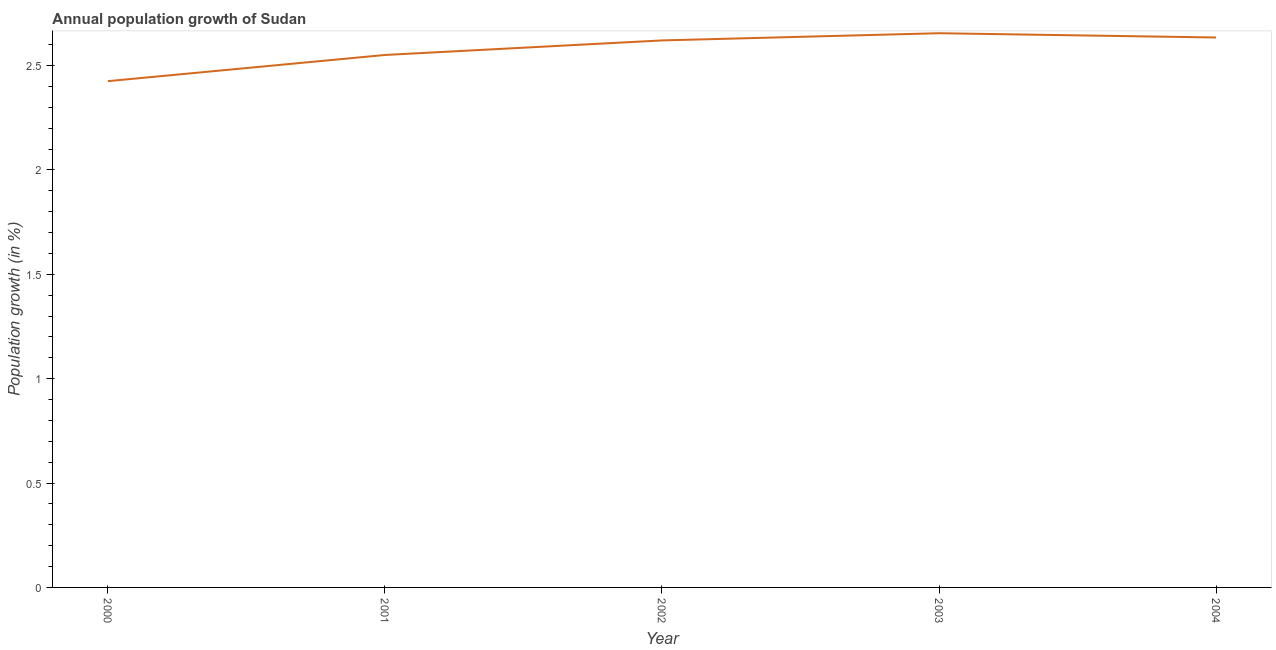What is the population growth in 2004?
Keep it short and to the point. 2.63. Across all years, what is the maximum population growth?
Your answer should be compact. 2.66. Across all years, what is the minimum population growth?
Make the answer very short. 2.43. In which year was the population growth minimum?
Provide a short and direct response. 2000. What is the sum of the population growth?
Keep it short and to the point. 12.89. What is the difference between the population growth in 2001 and 2002?
Give a very brief answer. -0.07. What is the average population growth per year?
Provide a succinct answer. 2.58. What is the median population growth?
Make the answer very short. 2.62. In how many years, is the population growth greater than 1.1 %?
Offer a very short reply. 5. Do a majority of the years between 2003 and 2000 (inclusive) have population growth greater than 1 %?
Provide a succinct answer. Yes. What is the ratio of the population growth in 2002 to that in 2003?
Your answer should be compact. 0.99. Is the population growth in 2000 less than that in 2002?
Your answer should be very brief. Yes. What is the difference between the highest and the second highest population growth?
Give a very brief answer. 0.02. Is the sum of the population growth in 2001 and 2002 greater than the maximum population growth across all years?
Keep it short and to the point. Yes. What is the difference between the highest and the lowest population growth?
Offer a terse response. 0.23. What is the difference between two consecutive major ticks on the Y-axis?
Make the answer very short. 0.5. Are the values on the major ticks of Y-axis written in scientific E-notation?
Ensure brevity in your answer.  No. What is the title of the graph?
Provide a succinct answer. Annual population growth of Sudan. What is the label or title of the X-axis?
Your response must be concise. Year. What is the label or title of the Y-axis?
Keep it short and to the point. Population growth (in %). What is the Population growth (in %) in 2000?
Your answer should be very brief. 2.43. What is the Population growth (in %) of 2001?
Give a very brief answer. 2.55. What is the Population growth (in %) of 2002?
Your response must be concise. 2.62. What is the Population growth (in %) in 2003?
Ensure brevity in your answer.  2.66. What is the Population growth (in %) in 2004?
Keep it short and to the point. 2.63. What is the difference between the Population growth (in %) in 2000 and 2001?
Your response must be concise. -0.13. What is the difference between the Population growth (in %) in 2000 and 2002?
Make the answer very short. -0.2. What is the difference between the Population growth (in %) in 2000 and 2003?
Offer a very short reply. -0.23. What is the difference between the Population growth (in %) in 2000 and 2004?
Your answer should be very brief. -0.21. What is the difference between the Population growth (in %) in 2001 and 2002?
Offer a terse response. -0.07. What is the difference between the Population growth (in %) in 2001 and 2003?
Provide a short and direct response. -0.1. What is the difference between the Population growth (in %) in 2001 and 2004?
Your answer should be very brief. -0.08. What is the difference between the Population growth (in %) in 2002 and 2003?
Provide a succinct answer. -0.03. What is the difference between the Population growth (in %) in 2002 and 2004?
Your answer should be compact. -0.01. What is the difference between the Population growth (in %) in 2003 and 2004?
Ensure brevity in your answer.  0.02. What is the ratio of the Population growth (in %) in 2000 to that in 2001?
Make the answer very short. 0.95. What is the ratio of the Population growth (in %) in 2000 to that in 2002?
Offer a very short reply. 0.93. What is the ratio of the Population growth (in %) in 2000 to that in 2003?
Provide a short and direct response. 0.91. What is the ratio of the Population growth (in %) in 2000 to that in 2004?
Ensure brevity in your answer.  0.92. What is the ratio of the Population growth (in %) in 2001 to that in 2003?
Your answer should be compact. 0.96. What is the ratio of the Population growth (in %) in 2001 to that in 2004?
Provide a short and direct response. 0.97. What is the ratio of the Population growth (in %) in 2002 to that in 2003?
Give a very brief answer. 0.99. What is the ratio of the Population growth (in %) in 2002 to that in 2004?
Your response must be concise. 0.99. 